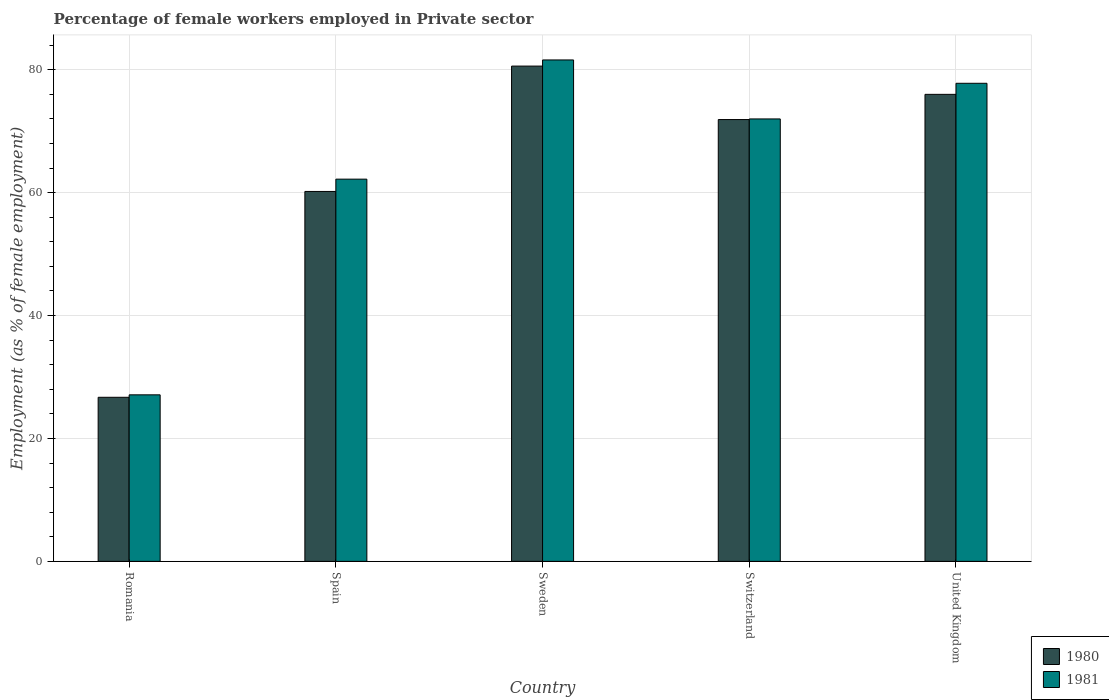How many different coloured bars are there?
Keep it short and to the point. 2. How many bars are there on the 3rd tick from the left?
Provide a short and direct response. 2. How many bars are there on the 1st tick from the right?
Offer a terse response. 2. What is the label of the 5th group of bars from the left?
Your answer should be very brief. United Kingdom. What is the percentage of females employed in Private sector in 1981 in Spain?
Make the answer very short. 62.2. Across all countries, what is the maximum percentage of females employed in Private sector in 1981?
Provide a short and direct response. 81.6. Across all countries, what is the minimum percentage of females employed in Private sector in 1980?
Offer a very short reply. 26.7. In which country was the percentage of females employed in Private sector in 1981 minimum?
Make the answer very short. Romania. What is the total percentage of females employed in Private sector in 1981 in the graph?
Offer a terse response. 320.7. What is the difference between the percentage of females employed in Private sector in 1981 in Spain and that in Sweden?
Ensure brevity in your answer.  -19.4. What is the difference between the percentage of females employed in Private sector in 1981 in Switzerland and the percentage of females employed in Private sector in 1980 in Romania?
Give a very brief answer. 45.3. What is the average percentage of females employed in Private sector in 1981 per country?
Your answer should be compact. 64.14. What is the ratio of the percentage of females employed in Private sector in 1981 in Sweden to that in United Kingdom?
Your answer should be very brief. 1.05. Is the difference between the percentage of females employed in Private sector in 1980 in Romania and Spain greater than the difference between the percentage of females employed in Private sector in 1981 in Romania and Spain?
Offer a terse response. Yes. What is the difference between the highest and the second highest percentage of females employed in Private sector in 1980?
Provide a short and direct response. 4.6. What is the difference between the highest and the lowest percentage of females employed in Private sector in 1980?
Keep it short and to the point. 53.9. In how many countries, is the percentage of females employed in Private sector in 1980 greater than the average percentage of females employed in Private sector in 1980 taken over all countries?
Give a very brief answer. 3. How many countries are there in the graph?
Keep it short and to the point. 5. What is the difference between two consecutive major ticks on the Y-axis?
Your answer should be very brief. 20. Where does the legend appear in the graph?
Your answer should be very brief. Bottom right. What is the title of the graph?
Make the answer very short. Percentage of female workers employed in Private sector. Does "2010" appear as one of the legend labels in the graph?
Provide a short and direct response. No. What is the label or title of the Y-axis?
Your answer should be compact. Employment (as % of female employment). What is the Employment (as % of female employment) in 1980 in Romania?
Keep it short and to the point. 26.7. What is the Employment (as % of female employment) in 1981 in Romania?
Your answer should be compact. 27.1. What is the Employment (as % of female employment) of 1980 in Spain?
Offer a very short reply. 60.2. What is the Employment (as % of female employment) of 1981 in Spain?
Ensure brevity in your answer.  62.2. What is the Employment (as % of female employment) of 1980 in Sweden?
Provide a short and direct response. 80.6. What is the Employment (as % of female employment) in 1981 in Sweden?
Offer a terse response. 81.6. What is the Employment (as % of female employment) in 1980 in Switzerland?
Your answer should be compact. 71.9. What is the Employment (as % of female employment) of 1981 in Switzerland?
Ensure brevity in your answer.  72. What is the Employment (as % of female employment) of 1980 in United Kingdom?
Your response must be concise. 76. What is the Employment (as % of female employment) in 1981 in United Kingdom?
Give a very brief answer. 77.8. Across all countries, what is the maximum Employment (as % of female employment) of 1980?
Your answer should be very brief. 80.6. Across all countries, what is the maximum Employment (as % of female employment) of 1981?
Give a very brief answer. 81.6. Across all countries, what is the minimum Employment (as % of female employment) of 1980?
Provide a succinct answer. 26.7. Across all countries, what is the minimum Employment (as % of female employment) in 1981?
Keep it short and to the point. 27.1. What is the total Employment (as % of female employment) of 1980 in the graph?
Offer a very short reply. 315.4. What is the total Employment (as % of female employment) of 1981 in the graph?
Provide a succinct answer. 320.7. What is the difference between the Employment (as % of female employment) of 1980 in Romania and that in Spain?
Your answer should be very brief. -33.5. What is the difference between the Employment (as % of female employment) of 1981 in Romania and that in Spain?
Provide a short and direct response. -35.1. What is the difference between the Employment (as % of female employment) of 1980 in Romania and that in Sweden?
Ensure brevity in your answer.  -53.9. What is the difference between the Employment (as % of female employment) of 1981 in Romania and that in Sweden?
Provide a short and direct response. -54.5. What is the difference between the Employment (as % of female employment) in 1980 in Romania and that in Switzerland?
Your answer should be very brief. -45.2. What is the difference between the Employment (as % of female employment) of 1981 in Romania and that in Switzerland?
Provide a succinct answer. -44.9. What is the difference between the Employment (as % of female employment) in 1980 in Romania and that in United Kingdom?
Your answer should be compact. -49.3. What is the difference between the Employment (as % of female employment) in 1981 in Romania and that in United Kingdom?
Offer a very short reply. -50.7. What is the difference between the Employment (as % of female employment) of 1980 in Spain and that in Sweden?
Offer a terse response. -20.4. What is the difference between the Employment (as % of female employment) in 1981 in Spain and that in Sweden?
Offer a very short reply. -19.4. What is the difference between the Employment (as % of female employment) in 1980 in Spain and that in United Kingdom?
Ensure brevity in your answer.  -15.8. What is the difference between the Employment (as % of female employment) of 1981 in Spain and that in United Kingdom?
Provide a succinct answer. -15.6. What is the difference between the Employment (as % of female employment) in 1980 in Sweden and that in Switzerland?
Your response must be concise. 8.7. What is the difference between the Employment (as % of female employment) in 1981 in Sweden and that in Switzerland?
Your answer should be very brief. 9.6. What is the difference between the Employment (as % of female employment) in 1980 in Sweden and that in United Kingdom?
Provide a short and direct response. 4.6. What is the difference between the Employment (as % of female employment) in 1981 in Sweden and that in United Kingdom?
Your answer should be very brief. 3.8. What is the difference between the Employment (as % of female employment) of 1980 in Switzerland and that in United Kingdom?
Give a very brief answer. -4.1. What is the difference between the Employment (as % of female employment) of 1981 in Switzerland and that in United Kingdom?
Give a very brief answer. -5.8. What is the difference between the Employment (as % of female employment) of 1980 in Romania and the Employment (as % of female employment) of 1981 in Spain?
Provide a short and direct response. -35.5. What is the difference between the Employment (as % of female employment) in 1980 in Romania and the Employment (as % of female employment) in 1981 in Sweden?
Make the answer very short. -54.9. What is the difference between the Employment (as % of female employment) of 1980 in Romania and the Employment (as % of female employment) of 1981 in Switzerland?
Provide a succinct answer. -45.3. What is the difference between the Employment (as % of female employment) of 1980 in Romania and the Employment (as % of female employment) of 1981 in United Kingdom?
Provide a short and direct response. -51.1. What is the difference between the Employment (as % of female employment) of 1980 in Spain and the Employment (as % of female employment) of 1981 in Sweden?
Ensure brevity in your answer.  -21.4. What is the difference between the Employment (as % of female employment) in 1980 in Spain and the Employment (as % of female employment) in 1981 in Switzerland?
Ensure brevity in your answer.  -11.8. What is the difference between the Employment (as % of female employment) of 1980 in Spain and the Employment (as % of female employment) of 1981 in United Kingdom?
Your answer should be very brief. -17.6. What is the difference between the Employment (as % of female employment) of 1980 in Sweden and the Employment (as % of female employment) of 1981 in Switzerland?
Provide a short and direct response. 8.6. What is the difference between the Employment (as % of female employment) in 1980 in Sweden and the Employment (as % of female employment) in 1981 in United Kingdom?
Make the answer very short. 2.8. What is the difference between the Employment (as % of female employment) of 1980 in Switzerland and the Employment (as % of female employment) of 1981 in United Kingdom?
Your answer should be compact. -5.9. What is the average Employment (as % of female employment) of 1980 per country?
Your answer should be very brief. 63.08. What is the average Employment (as % of female employment) in 1981 per country?
Ensure brevity in your answer.  64.14. What is the difference between the Employment (as % of female employment) of 1980 and Employment (as % of female employment) of 1981 in Spain?
Make the answer very short. -2. What is the difference between the Employment (as % of female employment) in 1980 and Employment (as % of female employment) in 1981 in Sweden?
Your answer should be very brief. -1. What is the difference between the Employment (as % of female employment) of 1980 and Employment (as % of female employment) of 1981 in Switzerland?
Your response must be concise. -0.1. What is the ratio of the Employment (as % of female employment) in 1980 in Romania to that in Spain?
Ensure brevity in your answer.  0.44. What is the ratio of the Employment (as % of female employment) of 1981 in Romania to that in Spain?
Offer a terse response. 0.44. What is the ratio of the Employment (as % of female employment) of 1980 in Romania to that in Sweden?
Keep it short and to the point. 0.33. What is the ratio of the Employment (as % of female employment) in 1981 in Romania to that in Sweden?
Provide a succinct answer. 0.33. What is the ratio of the Employment (as % of female employment) of 1980 in Romania to that in Switzerland?
Offer a very short reply. 0.37. What is the ratio of the Employment (as % of female employment) of 1981 in Romania to that in Switzerland?
Offer a very short reply. 0.38. What is the ratio of the Employment (as % of female employment) in 1980 in Romania to that in United Kingdom?
Ensure brevity in your answer.  0.35. What is the ratio of the Employment (as % of female employment) of 1981 in Romania to that in United Kingdom?
Provide a succinct answer. 0.35. What is the ratio of the Employment (as % of female employment) of 1980 in Spain to that in Sweden?
Provide a succinct answer. 0.75. What is the ratio of the Employment (as % of female employment) in 1981 in Spain to that in Sweden?
Your answer should be very brief. 0.76. What is the ratio of the Employment (as % of female employment) in 1980 in Spain to that in Switzerland?
Your answer should be very brief. 0.84. What is the ratio of the Employment (as % of female employment) in 1981 in Spain to that in Switzerland?
Provide a short and direct response. 0.86. What is the ratio of the Employment (as % of female employment) of 1980 in Spain to that in United Kingdom?
Ensure brevity in your answer.  0.79. What is the ratio of the Employment (as % of female employment) of 1981 in Spain to that in United Kingdom?
Your answer should be very brief. 0.8. What is the ratio of the Employment (as % of female employment) in 1980 in Sweden to that in Switzerland?
Offer a very short reply. 1.12. What is the ratio of the Employment (as % of female employment) of 1981 in Sweden to that in Switzerland?
Offer a very short reply. 1.13. What is the ratio of the Employment (as % of female employment) of 1980 in Sweden to that in United Kingdom?
Your response must be concise. 1.06. What is the ratio of the Employment (as % of female employment) of 1981 in Sweden to that in United Kingdom?
Offer a very short reply. 1.05. What is the ratio of the Employment (as % of female employment) in 1980 in Switzerland to that in United Kingdom?
Your answer should be very brief. 0.95. What is the ratio of the Employment (as % of female employment) of 1981 in Switzerland to that in United Kingdom?
Make the answer very short. 0.93. What is the difference between the highest and the lowest Employment (as % of female employment) of 1980?
Provide a succinct answer. 53.9. What is the difference between the highest and the lowest Employment (as % of female employment) in 1981?
Give a very brief answer. 54.5. 